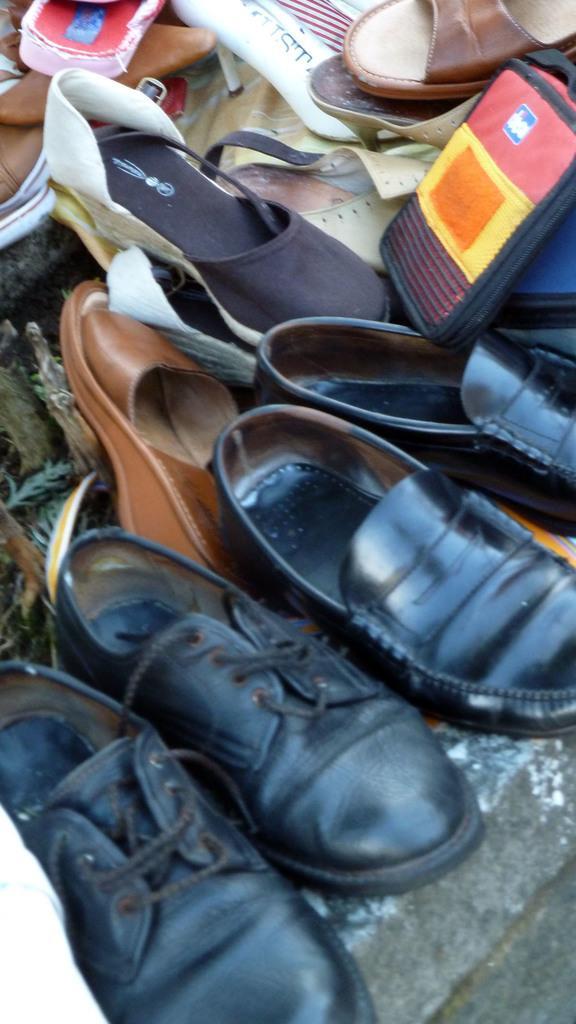Can you describe this image briefly? In this picture I can see there are a pair of shoes and sandals placed on the floor. 